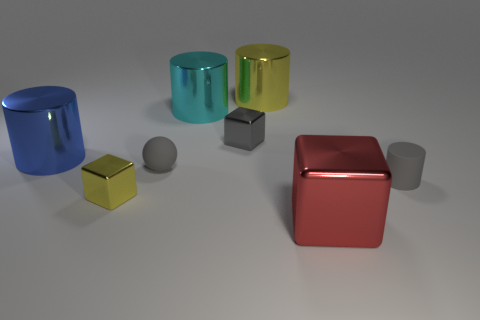Subtract all rubber cylinders. How many cylinders are left? 3 Subtract all blue cylinders. How many cylinders are left? 3 Add 2 tiny rubber spheres. How many objects exist? 10 Subtract 1 spheres. How many spheres are left? 0 Subtract all green blocks. Subtract all cyan spheres. How many blocks are left? 3 Subtract all large cyan metallic cylinders. Subtract all tiny gray matte balls. How many objects are left? 6 Add 7 red metallic blocks. How many red metallic blocks are left? 8 Add 4 yellow objects. How many yellow objects exist? 6 Subtract 0 green spheres. How many objects are left? 8 Subtract all spheres. How many objects are left? 7 